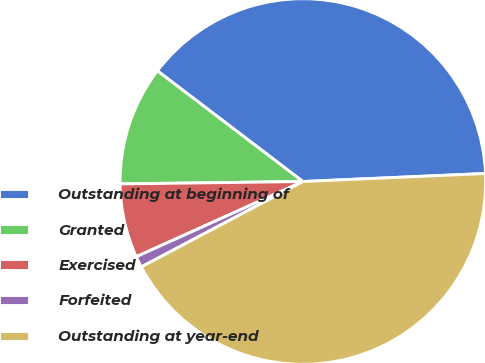Convert chart. <chart><loc_0><loc_0><loc_500><loc_500><pie_chart><fcel>Outstanding at beginning of<fcel>Granted<fcel>Exercised<fcel>Forfeited<fcel>Outstanding at year-end<nl><fcel>38.95%<fcel>10.56%<fcel>6.54%<fcel>0.99%<fcel>42.96%<nl></chart> 